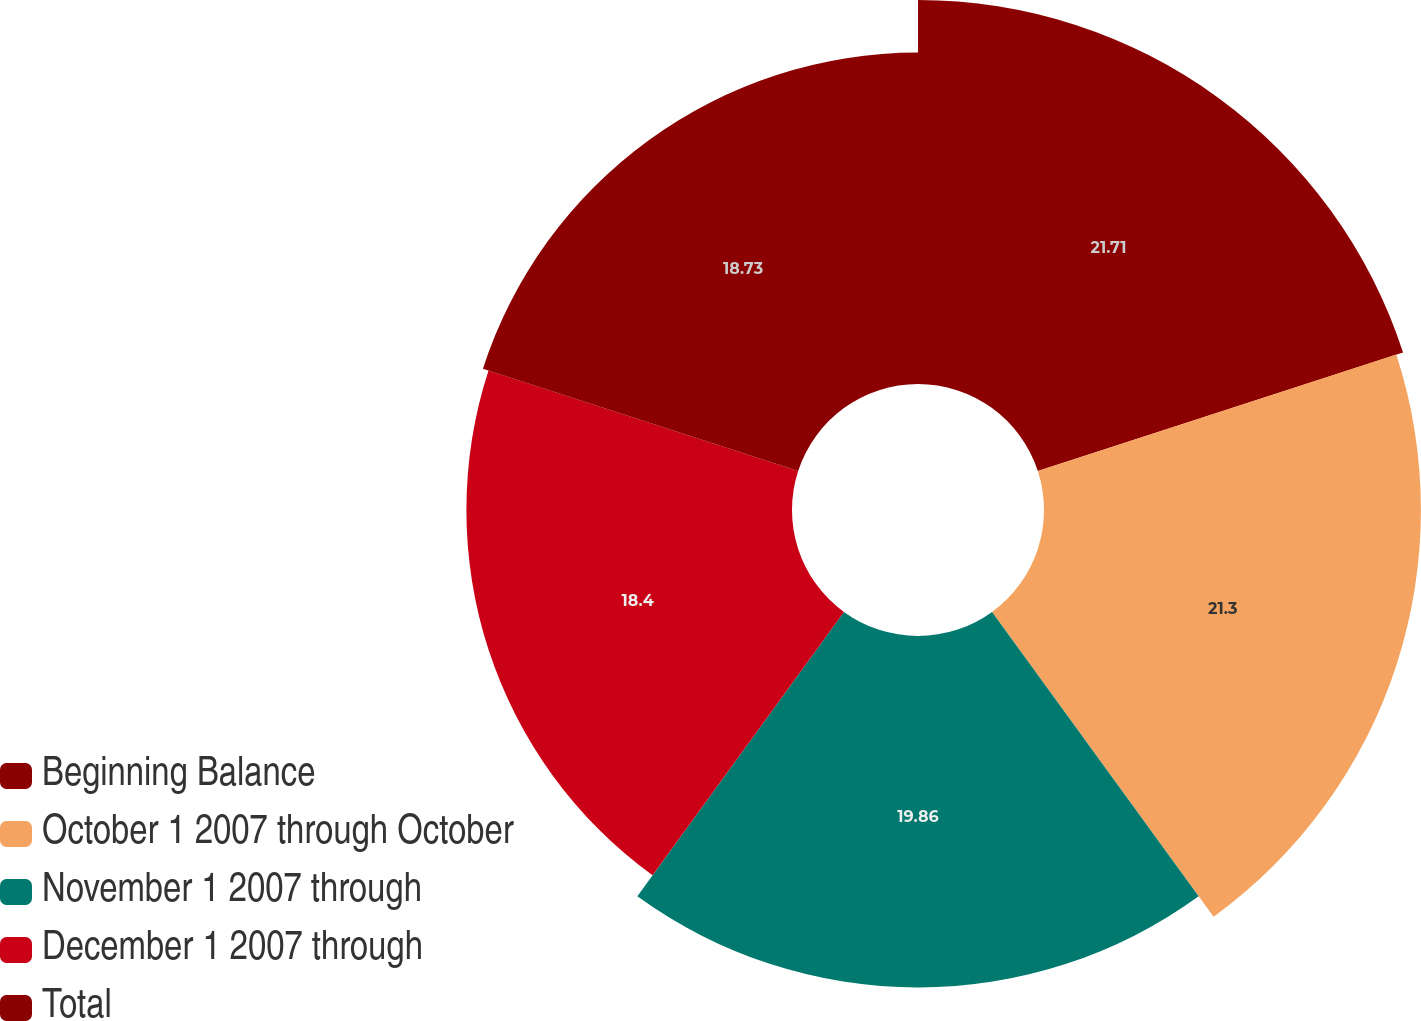Convert chart. <chart><loc_0><loc_0><loc_500><loc_500><pie_chart><fcel>Beginning Balance<fcel>October 1 2007 through October<fcel>November 1 2007 through<fcel>December 1 2007 through<fcel>Total<nl><fcel>21.7%<fcel>21.3%<fcel>19.86%<fcel>18.4%<fcel>18.73%<nl></chart> 